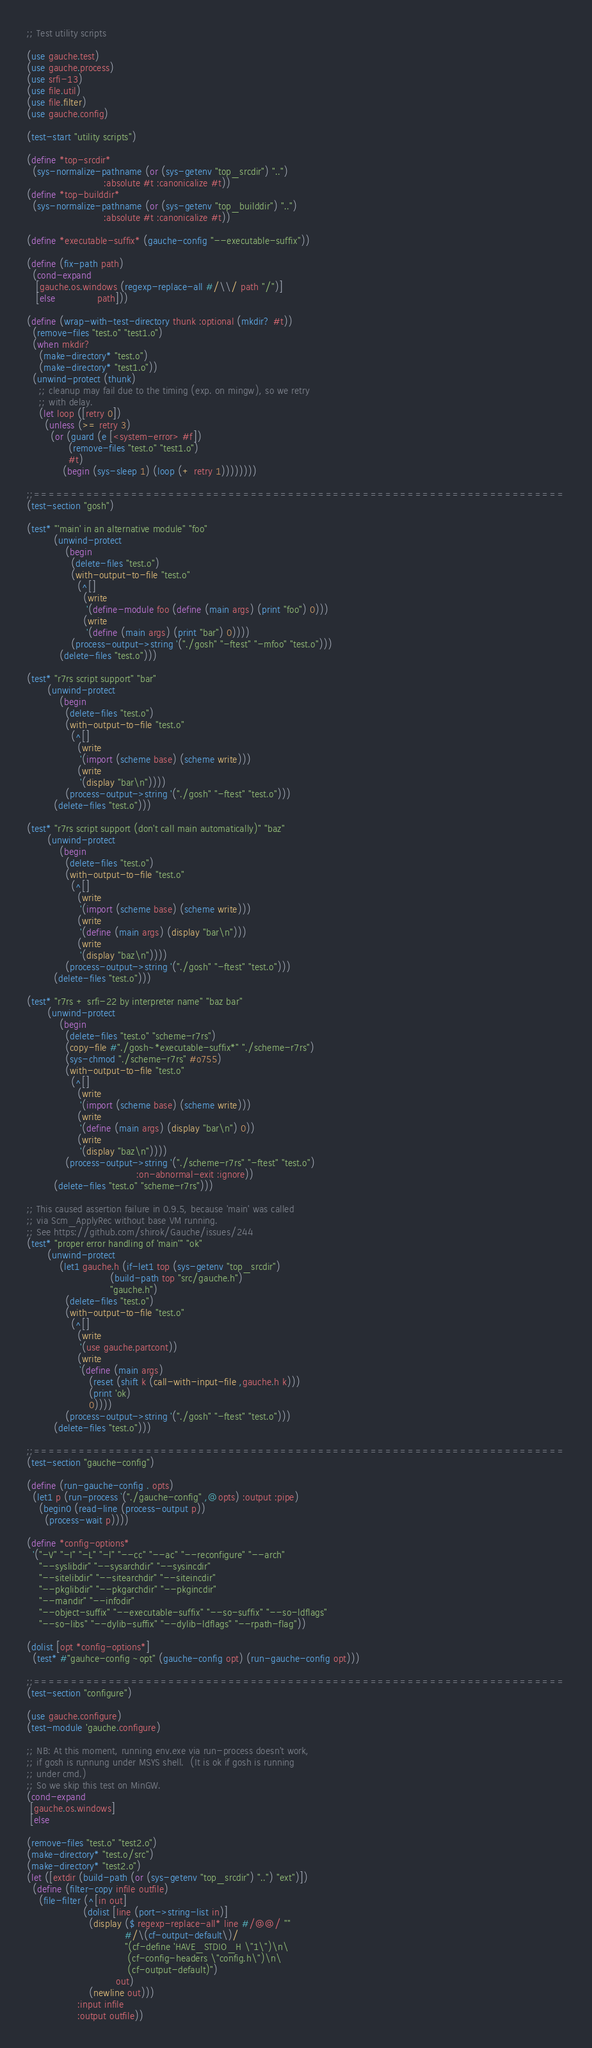Convert code to text. <code><loc_0><loc_0><loc_500><loc_500><_Scheme_>;; Test utility scripts

(use gauche.test)
(use gauche.process)
(use srfi-13)
(use file.util)
(use file.filter)
(use gauche.config)

(test-start "utility scripts")

(define *top-srcdir*
  (sys-normalize-pathname (or (sys-getenv "top_srcdir") "..")
                          :absolute #t :canonicalize #t))
(define *top-builddir*
  (sys-normalize-pathname (or (sys-getenv "top_builddir") "..")
                          :absolute #t :canonicalize #t))

(define *executable-suffix* (gauche-config "--executable-suffix"))

(define (fix-path path)
  (cond-expand
   [gauche.os.windows (regexp-replace-all #/\\/ path "/")]
   [else              path]))

(define (wrap-with-test-directory thunk :optional (mkdir? #t))
  (remove-files "test.o" "test1.o")
  (when mkdir?
    (make-directory* "test.o")
    (make-directory* "test1.o"))
  (unwind-protect (thunk)
    ;; cleanup may fail due to the timing (exp. on mingw), so we retry
    ;; with delay.
    (let loop ([retry 0])
      (unless (>= retry 3)
        (or (guard (e [<system-error> #f])
              (remove-files "test.o" "test1.o")
              #t)
            (begin (sys-sleep 1) (loop (+ retry 1))))))))

;;=======================================================================
(test-section "gosh")

(test* "'main' in an alternative module" "foo"
         (unwind-protect
             (begin
               (delete-files "test.o")
               (with-output-to-file "test.o"
                 (^[]
                   (write
                    '(define-module foo (define (main args) (print "foo") 0)))
                   (write
                    '(define (main args) (print "bar") 0))))
               (process-output->string '("./gosh" "-ftest" "-mfoo" "test.o")))
           (delete-files "test.o")))

(test* "r7rs script support" "bar"
       (unwind-protect
           (begin
             (delete-files "test.o")
             (with-output-to-file "test.o"
               (^[]
                 (write
                  '(import (scheme base) (scheme write)))
                 (write
                  '(display "bar\n"))))
             (process-output->string '("./gosh" "-ftest" "test.o")))
         (delete-files "test.o")))

(test* "r7rs script support (don't call main automatically)" "baz"
       (unwind-protect
           (begin
             (delete-files "test.o")
             (with-output-to-file "test.o"
               (^[]
                 (write
                  '(import (scheme base) (scheme write)))
                 (write
                  '(define (main args) (display "bar\n")))
                 (write
                  '(display "baz\n"))))
             (process-output->string '("./gosh" "-ftest" "test.o")))
         (delete-files "test.o")))

(test* "r7rs + srfi-22 by interpreter name" "baz bar"
       (unwind-protect
           (begin
             (delete-files "test.o" "scheme-r7rs")
             (copy-file #"./gosh~*executable-suffix*" "./scheme-r7rs")
             (sys-chmod "./scheme-r7rs" #o755)
             (with-output-to-file "test.o"
               (^[]
                 (write
                  '(import (scheme base) (scheme write)))
                 (write
                  '(define (main args) (display "bar\n") 0))
                 (write
                  '(display "baz\n"))))
             (process-output->string '("./scheme-r7rs" "-ftest" "test.o")
                                     :on-abnormal-exit :ignore))
         (delete-files "test.o" "scheme-r7rs")))

;; This caused assertion failure in 0.9.5, because 'main' was called
;; via Scm_ApplyRec without base VM running.
;; See https://github.com/shirok/Gauche/issues/244
(test* "proper error handling of 'main'" "ok"
       (unwind-protect
           (let1 gauche.h (if-let1 top (sys-getenv "top_srcdir")
                            (build-path top "src/gauche.h")
                            "gauche.h")
             (delete-files "test.o")
             (with-output-to-file "test.o"
               (^[]
                 (write
                  '(use gauche.partcont))
                 (write
                  `(define (main args)
                     (reset (shift k (call-with-input-file ,gauche.h k)))
                     (print 'ok)
                     0))))
             (process-output->string '("./gosh" "-ftest" "test.o")))
         (delete-files "test.o")))

;;=======================================================================
(test-section "gauche-config")

(define (run-gauche-config . opts)
  (let1 p (run-process `("./gauche-config" ,@opts) :output :pipe)
    (begin0 (read-line (process-output p))
      (process-wait p))))

(define *config-options*
  '("-V" "-I" "-L" "-l" "--cc" "--ac" "--reconfigure" "--arch"
    "--syslibdir" "--sysarchdir" "--sysincdir"
    "--sitelibdir" "--sitearchdir" "--siteincdir"
    "--pkglibdir" "--pkgarchdir" "--pkgincdir"
    "--mandir" "--infodir"
    "--object-suffix" "--executable-suffix" "--so-suffix" "--so-ldflags"
    "--so-libs" "--dylib-suffix" "--dylib-ldflags" "--rpath-flag"))

(dolist [opt *config-options*]
  (test* #"gauhce-config ~opt" (gauche-config opt) (run-gauche-config opt)))

;;=======================================================================
(test-section "configure")

(use gauche.configure)
(test-module 'gauche.configure)

;; NB: At this moment, running env.exe via run-process doesn't work,
;; if gosh is runnung under MSYS shell.  (It is ok if gosh is running
;; under cmd.)
;; So we skip this test on MinGW.
(cond-expand
 [gauche.os.windows]
 [else

(remove-files "test.o" "test2.o")
(make-directory* "test.o/src")
(make-directory* "test2.o")
(let ([extdir (build-path (or (sys-getenv "top_srcdir") "..") "ext")])
  (define (filter-copy infile outfile)
    (file-filter (^[in out]
                   (dolist [line (port->string-list in)]
                     (display ($ regexp-replace-all* line #/@@/ ""
                                 #/\(cf-output-default\)/
                                 "(cf-define 'HAVE_STDIO_H \"1\")\n\
                                  (cf-config-headers \"config.h\")\n\
                                  (cf-output-default)")
                              out)
                     (newline out)))
                 :input infile
                 :output outfile))</code> 